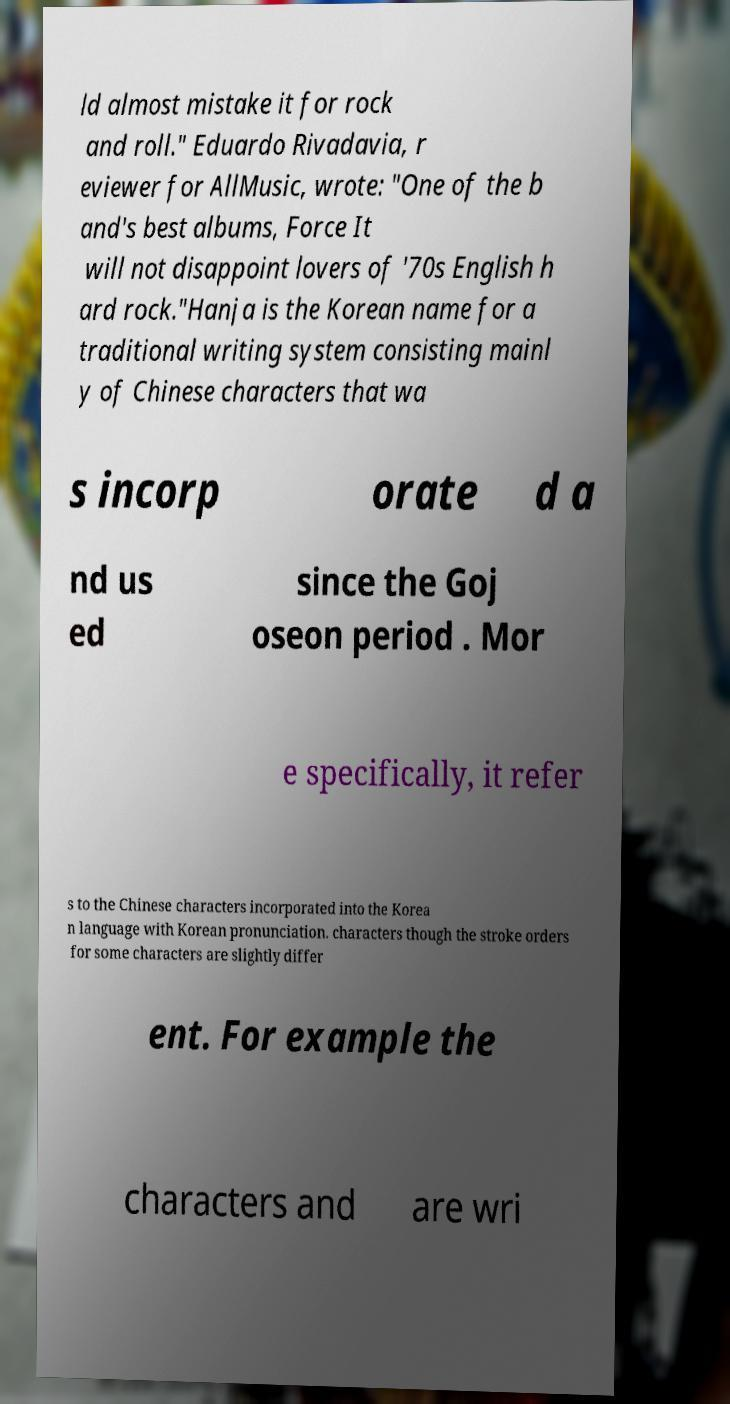I need the written content from this picture converted into text. Can you do that? ld almost mistake it for rock and roll." Eduardo Rivadavia, r eviewer for AllMusic, wrote: "One of the b and's best albums, Force It will not disappoint lovers of '70s English h ard rock."Hanja is the Korean name for a traditional writing system consisting mainl y of Chinese characters that wa s incorp orate d a nd us ed since the Goj oseon period . Mor e specifically, it refer s to the Chinese characters incorporated into the Korea n language with Korean pronunciation. characters though the stroke orders for some characters are slightly differ ent. For example the characters and are wri 